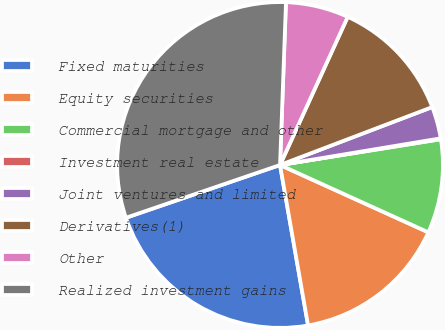Convert chart to OTSL. <chart><loc_0><loc_0><loc_500><loc_500><pie_chart><fcel>Fixed maturities<fcel>Equity securities<fcel>Commercial mortgage and other<fcel>Investment real estate<fcel>Joint ventures and limited<fcel>Derivatives(1)<fcel>Other<fcel>Realized investment gains<nl><fcel>22.5%<fcel>15.46%<fcel>9.31%<fcel>0.09%<fcel>3.17%<fcel>12.39%<fcel>6.24%<fcel>30.83%<nl></chart> 